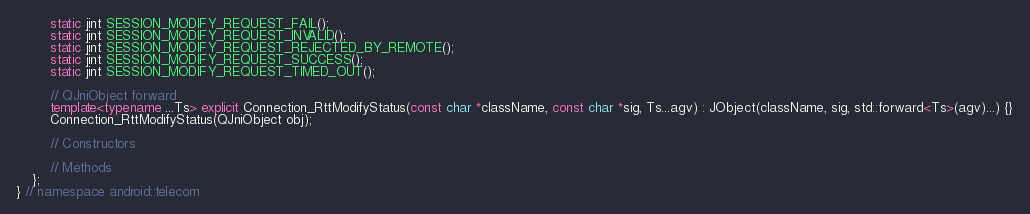<code> <loc_0><loc_0><loc_500><loc_500><_C++_>		static jint SESSION_MODIFY_REQUEST_FAIL();
		static jint SESSION_MODIFY_REQUEST_INVALID();
		static jint SESSION_MODIFY_REQUEST_REJECTED_BY_REMOTE();
		static jint SESSION_MODIFY_REQUEST_SUCCESS();
		static jint SESSION_MODIFY_REQUEST_TIMED_OUT();
		
		// QJniObject forward
		template<typename ...Ts> explicit Connection_RttModifyStatus(const char *className, const char *sig, Ts...agv) : JObject(className, sig, std::forward<Ts>(agv)...) {}
		Connection_RttModifyStatus(QJniObject obj);
		
		// Constructors
		
		// Methods
	};
} // namespace android::telecom

</code> 